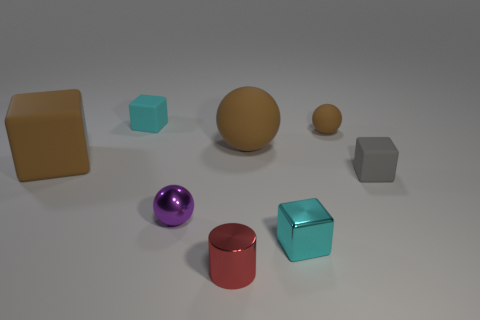Subtract all big brown rubber cubes. How many cubes are left? 3 Subtract all spheres. How many objects are left? 5 Add 1 big cyan rubber cubes. How many objects exist? 9 Subtract all blue cubes. How many green cylinders are left? 0 Subtract all big green cylinders. Subtract all small metal cylinders. How many objects are left? 7 Add 8 small cylinders. How many small cylinders are left? 9 Add 2 small brown spheres. How many small brown spheres exist? 3 Subtract all brown balls. How many balls are left? 1 Subtract 1 purple balls. How many objects are left? 7 Subtract 1 spheres. How many spheres are left? 2 